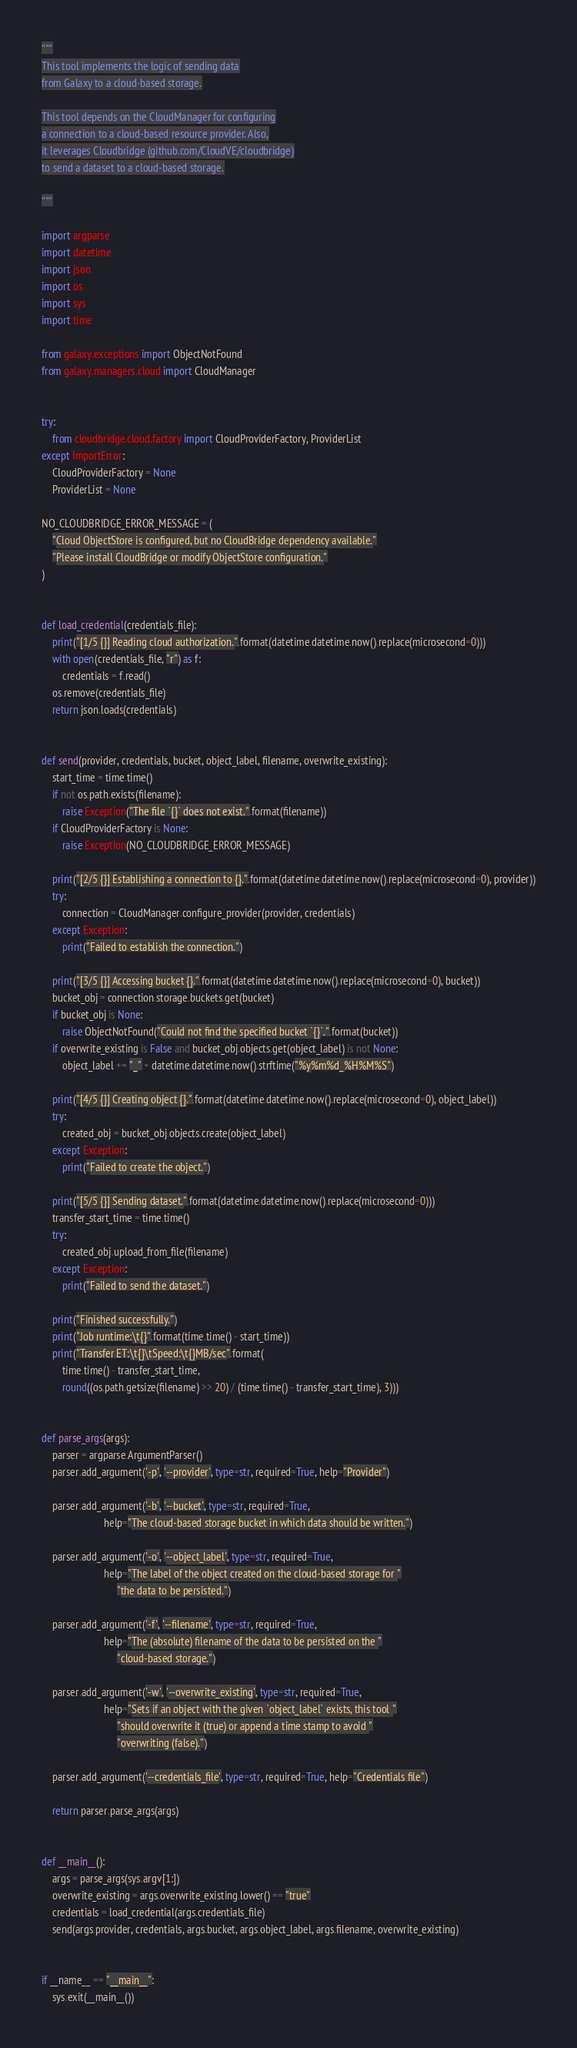Convert code to text. <code><loc_0><loc_0><loc_500><loc_500><_Python_>"""
This tool implements the logic of sending data
from Galaxy to a cloud-based storage.

This tool depends on the CloudManager for configuring
a connection to a cloud-based resource provider. Also,
it leverages Cloudbridge (github.com/CloudVE/cloudbridge)
to send a dataset to a cloud-based storage.

"""

import argparse
import datetime
import json
import os
import sys
import time

from galaxy.exceptions import ObjectNotFound
from galaxy.managers.cloud import CloudManager


try:
    from cloudbridge.cloud.factory import CloudProviderFactory, ProviderList
except ImportError:
    CloudProviderFactory = None
    ProviderList = None

NO_CLOUDBRIDGE_ERROR_MESSAGE = (
    "Cloud ObjectStore is configured, but no CloudBridge dependency available."
    "Please install CloudBridge or modify ObjectStore configuration."
)


def load_credential(credentials_file):
    print("[1/5 {}] Reading cloud authorization.".format(datetime.datetime.now().replace(microsecond=0)))
    with open(credentials_file, "r") as f:
        credentials = f.read()
    os.remove(credentials_file)
    return json.loads(credentials)


def send(provider, credentials, bucket, object_label, filename, overwrite_existing):
    start_time = time.time()
    if not os.path.exists(filename):
        raise Exception("The file `{}` does not exist.".format(filename))
    if CloudProviderFactory is None:
        raise Exception(NO_CLOUDBRIDGE_ERROR_MESSAGE)

    print("[2/5 {}] Establishing a connection to {}.".format(datetime.datetime.now().replace(microsecond=0), provider))
    try:
        connection = CloudManager.configure_provider(provider, credentials)
    except Exception:
        print("Failed to establish the connection.")

    print("[3/5 {}] Accessing bucket {}.".format(datetime.datetime.now().replace(microsecond=0), bucket))
    bucket_obj = connection.storage.buckets.get(bucket)
    if bucket_obj is None:
        raise ObjectNotFound("Could not find the specified bucket `{}`.".format(bucket))
    if overwrite_existing is False and bucket_obj.objects.get(object_label) is not None:
        object_label += "_" + datetime.datetime.now().strftime("%y%m%d_%H%M%S")

    print("[4/5 {}] Creating object {}.".format(datetime.datetime.now().replace(microsecond=0), object_label))
    try:
        created_obj = bucket_obj.objects.create(object_label)
    except Exception:
        print("Failed to create the object.")

    print("[5/5 {}] Sending dataset.".format(datetime.datetime.now().replace(microsecond=0)))
    transfer_start_time = time.time()
    try:
        created_obj.upload_from_file(filename)
    except Exception:
        print("Failed to send the dataset.")

    print("Finished successfully.")
    print("Job runtime:\t{}".format(time.time() - start_time))
    print("Transfer ET:\t{}\tSpeed:\t{}MB/sec".format(
        time.time() - transfer_start_time,
        round((os.path.getsize(filename) >> 20) / (time.time() - transfer_start_time), 3)))


def parse_args(args):
    parser = argparse.ArgumentParser()
    parser.add_argument('-p', '--provider', type=str, required=True, help="Provider")

    parser.add_argument('-b', '--bucket', type=str, required=True,
                        help="The cloud-based storage bucket in which data should be written.")

    parser.add_argument('-o', '--object_label', type=str, required=True,
                        help="The label of the object created on the cloud-based storage for "
                             "the data to be persisted.")

    parser.add_argument('-f', '--filename', type=str, required=True,
                        help="The (absolute) filename of the data to be persisted on the "
                             "cloud-based storage.")

    parser.add_argument('-w', '--overwrite_existing', type=str, required=True,
                        help="Sets if an object with the given `object_label` exists, this tool "
                             "should overwrite it (true) or append a time stamp to avoid "
                             "overwriting (false).")

    parser.add_argument('--credentials_file', type=str, required=True, help="Credentials file")

    return parser.parse_args(args)


def __main__():
    args = parse_args(sys.argv[1:])
    overwrite_existing = args.overwrite_existing.lower() == "true"
    credentials = load_credential(args.credentials_file)
    send(args.provider, credentials, args.bucket, args.object_label, args.filename, overwrite_existing)


if __name__ == "__main__":
    sys.exit(__main__())
</code> 